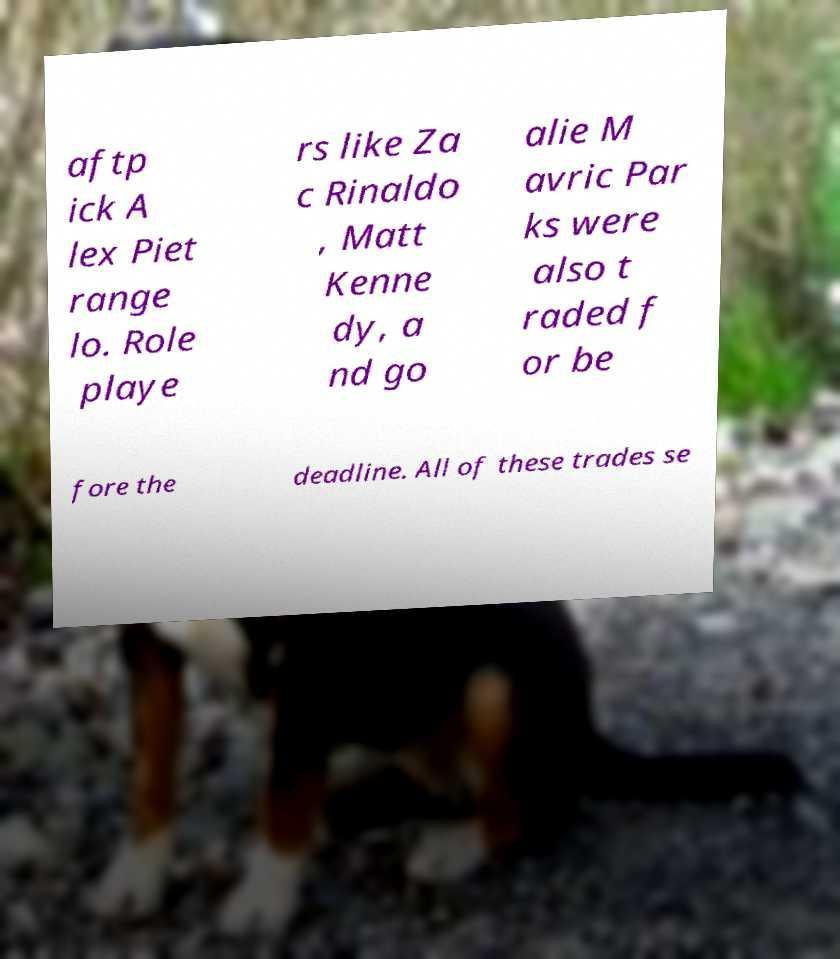There's text embedded in this image that I need extracted. Can you transcribe it verbatim? aftp ick A lex Piet range lo. Role playe rs like Za c Rinaldo , Matt Kenne dy, a nd go alie M avric Par ks were also t raded f or be fore the deadline. All of these trades se 